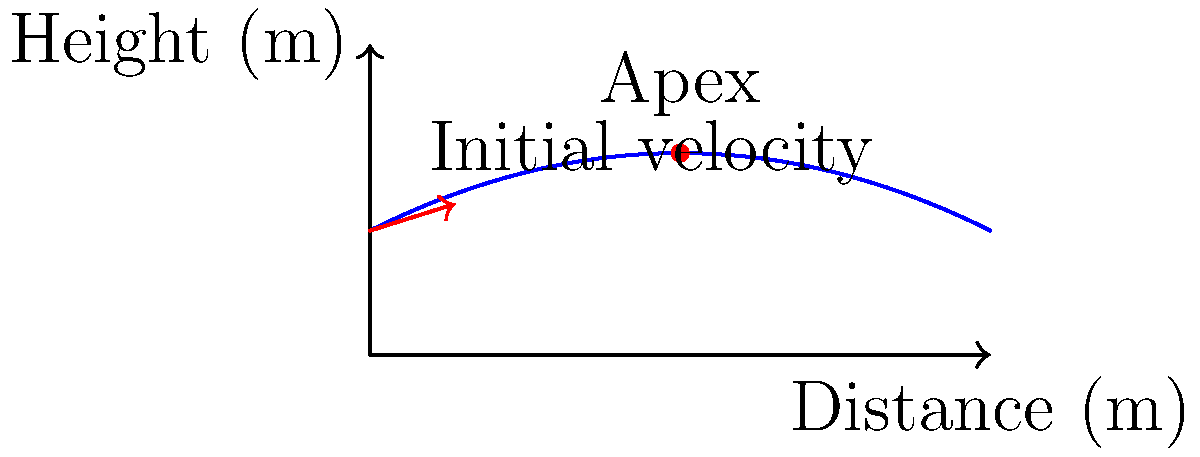As a proud alumnus of Asheboro High School, you're watching a basketball game in your old gym. The star player takes a shot, and you notice the trajectory of the ball follows a parabolic path. If the initial velocity of the ball is 8 m/s at an angle of 60° to the horizontal, and the release height is 2 meters, what is the maximum height reached by the ball? Let's approach this step-by-step:

1) The trajectory of a projectile (like a basketball) follows a parabolic path, as shown in the diagram.

2) To find the maximum height, we need to use the equation:

   $$h_{max} = h_0 + \frac{v_0^2 \sin^2 \theta}{2g}$$

   Where:
   $h_{max}$ is the maximum height
   $h_0$ is the initial height
   $v_0$ is the initial velocity
   $\theta$ is the launch angle
   $g$ is the acceleration due to gravity (9.8 m/s²)

3) We're given:
   $h_0 = 2$ m
   $v_0 = 8$ m/s
   $\theta = 60°$

4) Let's substitute these values:

   $$h_{max} = 2 + \frac{8^2 \sin^2 60°}{2(9.8)}$$

5) Simplify:
   $\sin 60° = \frac{\sqrt{3}}{2}$
   
   $$h_{max} = 2 + \frac{64 (\frac{3}{4})}{19.6}$$

6) Calculate:

   $$h_{max} = 2 + \frac{48}{19.6} \approx 4.45 \text{ m}$$

Therefore, the maximum height reached by the ball is approximately 4.45 meters.
Answer: 4.45 meters 